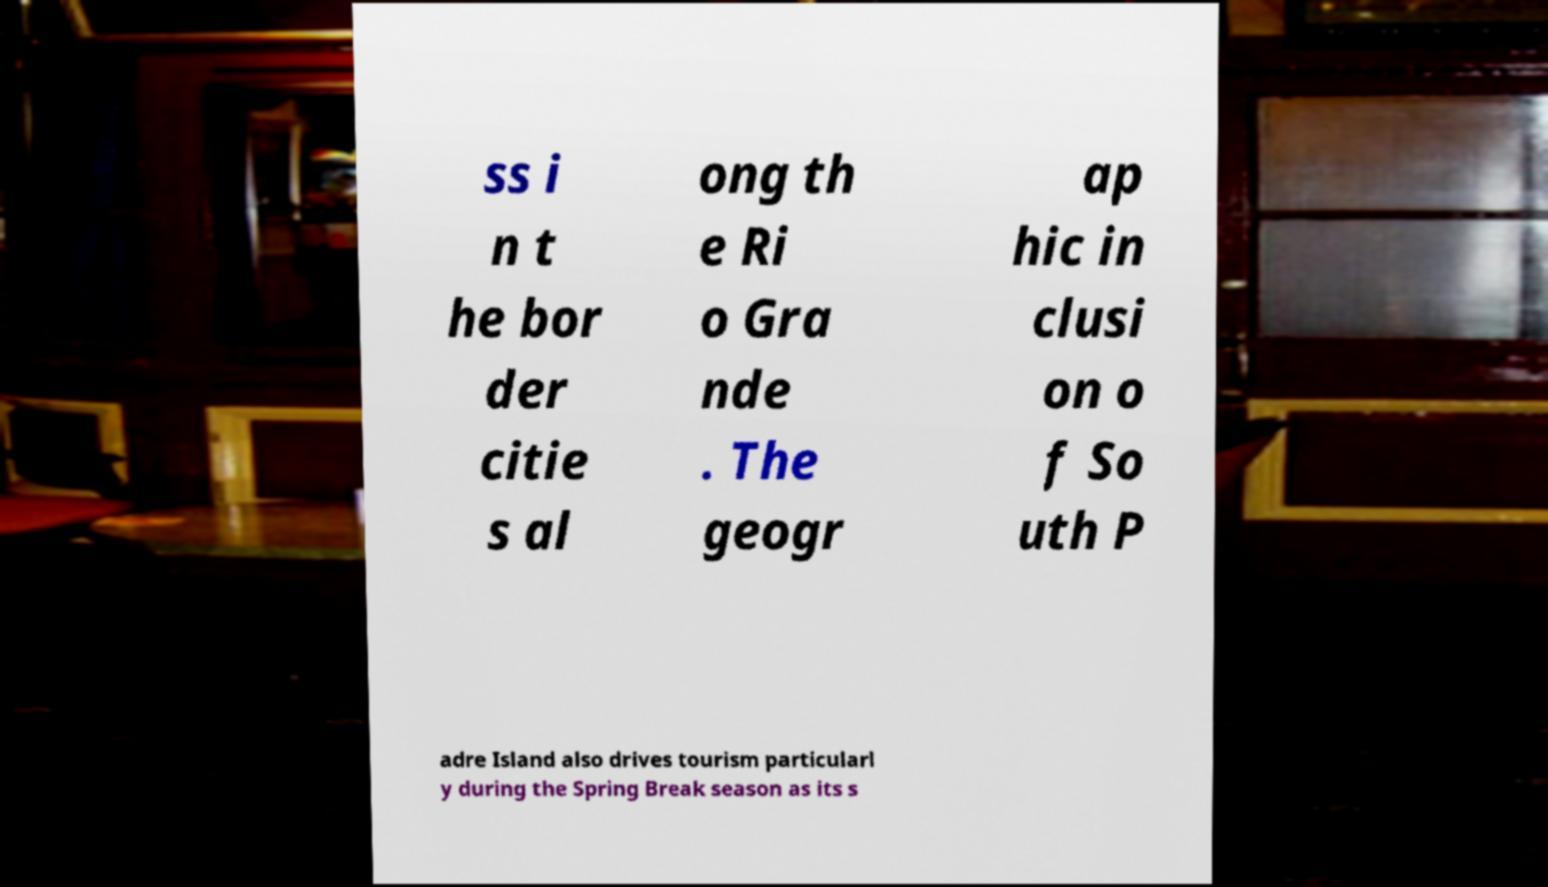Can you accurately transcribe the text from the provided image for me? ss i n t he bor der citie s al ong th e Ri o Gra nde . The geogr ap hic in clusi on o f So uth P adre Island also drives tourism particularl y during the Spring Break season as its s 